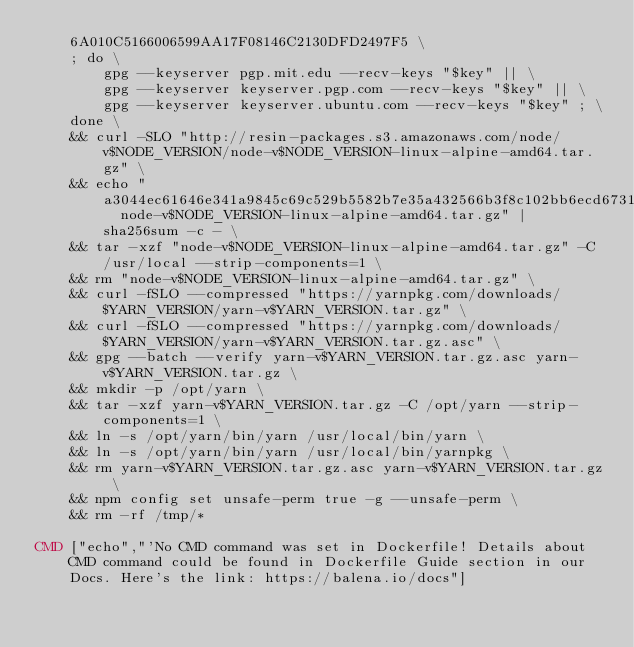<code> <loc_0><loc_0><loc_500><loc_500><_Dockerfile_>	6A010C5166006599AA17F08146C2130DFD2497F5 \
	; do \
		gpg --keyserver pgp.mit.edu --recv-keys "$key" || \
		gpg --keyserver keyserver.pgp.com --recv-keys "$key" || \
		gpg --keyserver keyserver.ubuntu.com --recv-keys "$key" ; \
	done \
	&& curl -SLO "http://resin-packages.s3.amazonaws.com/node/v$NODE_VERSION/node-v$NODE_VERSION-linux-alpine-amd64.tar.gz" \
	&& echo "a3044ec61646e341a9845c69c529b5582b7e35a432566b3f8c102bb6ecd67318  node-v$NODE_VERSION-linux-alpine-amd64.tar.gz" | sha256sum -c - \
	&& tar -xzf "node-v$NODE_VERSION-linux-alpine-amd64.tar.gz" -C /usr/local --strip-components=1 \
	&& rm "node-v$NODE_VERSION-linux-alpine-amd64.tar.gz" \
	&& curl -fSLO --compressed "https://yarnpkg.com/downloads/$YARN_VERSION/yarn-v$YARN_VERSION.tar.gz" \
	&& curl -fSLO --compressed "https://yarnpkg.com/downloads/$YARN_VERSION/yarn-v$YARN_VERSION.tar.gz.asc" \
	&& gpg --batch --verify yarn-v$YARN_VERSION.tar.gz.asc yarn-v$YARN_VERSION.tar.gz \
	&& mkdir -p /opt/yarn \
	&& tar -xzf yarn-v$YARN_VERSION.tar.gz -C /opt/yarn --strip-components=1 \
	&& ln -s /opt/yarn/bin/yarn /usr/local/bin/yarn \
	&& ln -s /opt/yarn/bin/yarn /usr/local/bin/yarnpkg \
	&& rm yarn-v$YARN_VERSION.tar.gz.asc yarn-v$YARN_VERSION.tar.gz \
	&& npm config set unsafe-perm true -g --unsafe-perm \
	&& rm -rf /tmp/*

CMD ["echo","'No CMD command was set in Dockerfile! Details about CMD command could be found in Dockerfile Guide section in our Docs. Here's the link: https://balena.io/docs"]
</code> 